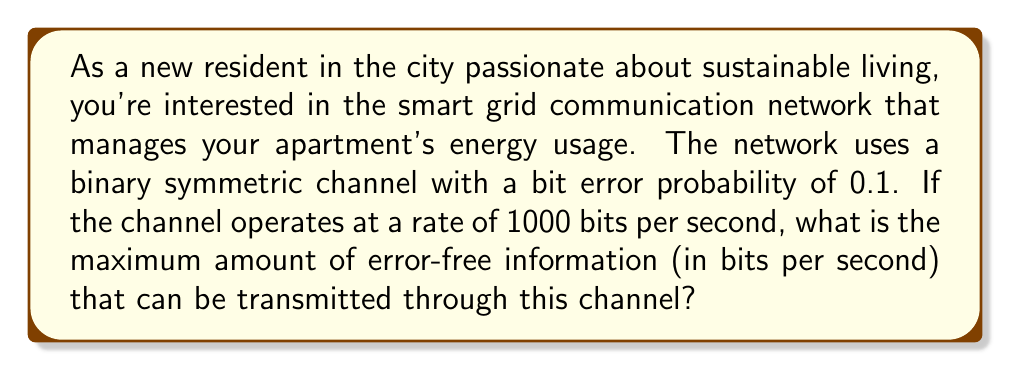Could you help me with this problem? To solve this problem, we need to use the concept of channel capacity from information theory. For a binary symmetric channel (BSC), the channel capacity is given by:

$$C = 1 - H(p)$$

Where $C$ is the channel capacity in bits per channel use, and $H(p)$ is the binary entropy function:

$$H(p) = -p \log_2(p) - (1-p) \log_2(1-p)$$

Here, $p$ is the bit error probability, which is given as 0.1.

Let's calculate step by step:

1) First, we need to calculate $H(0.1)$:

   $$H(0.1) = -0.1 \log_2(0.1) - 0.9 \log_2(0.9)$$

2) Using a calculator or computer:

   $$H(0.1) \approx 0.469$$

3) Now we can calculate the channel capacity per use:

   $$C = 1 - H(0.1) \approx 1 - 0.469 = 0.531$$

4) This means that for each bit sent, we can transmit 0.531 bits of error-free information.

5) The channel operates at 1000 bits per second, so to get the capacity in bits per second, we multiply:

   $$C_{bps} = 0.531 \times 1000 = 531$$

Therefore, the maximum amount of error-free information that can be transmitted through this channel is approximately 531 bits per second.
Answer: 531 bits per second 